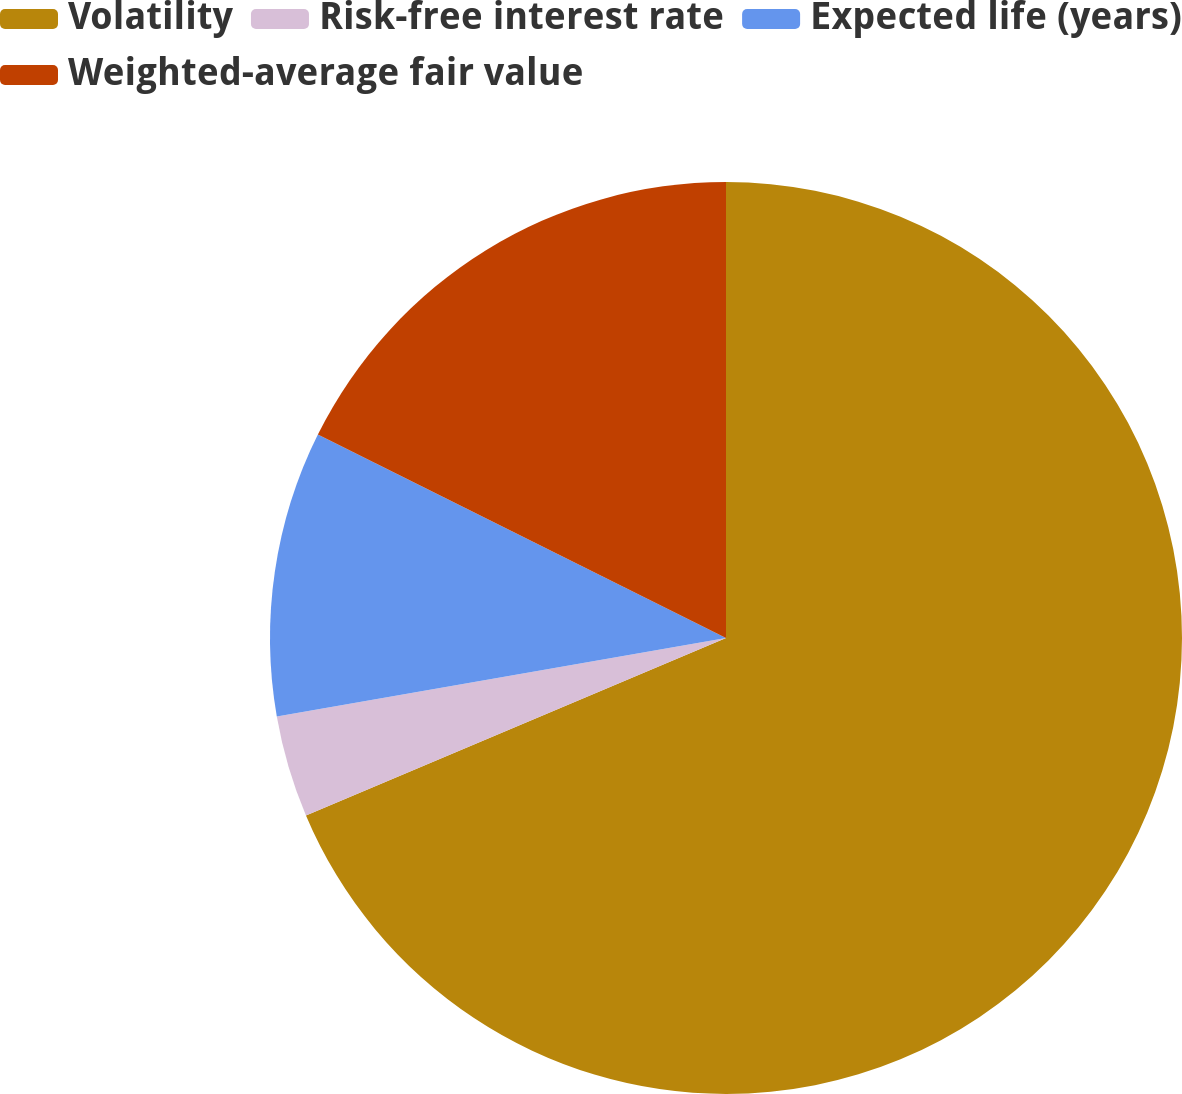Convert chart to OTSL. <chart><loc_0><loc_0><loc_500><loc_500><pie_chart><fcel>Volatility<fcel>Risk-free interest rate<fcel>Expected life (years)<fcel>Weighted-average fair value<nl><fcel>68.63%<fcel>3.61%<fcel>10.11%<fcel>17.64%<nl></chart> 